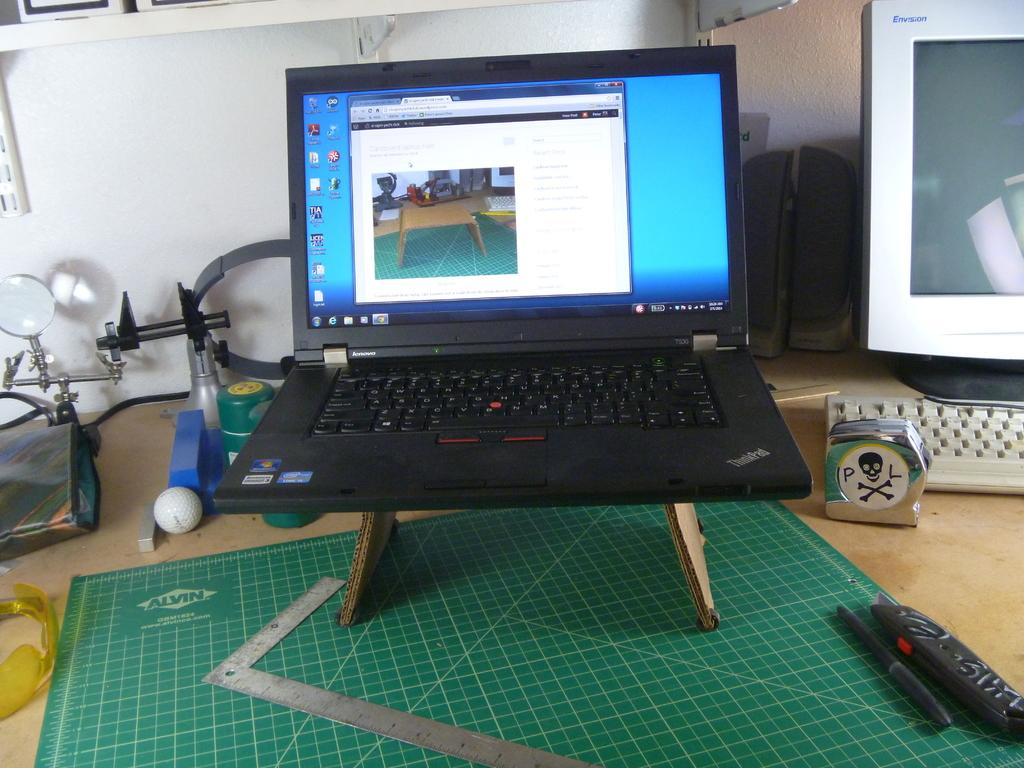Provide a one-sentence caption for the provided image. A lenovo laptop is on a stand on a desk. 